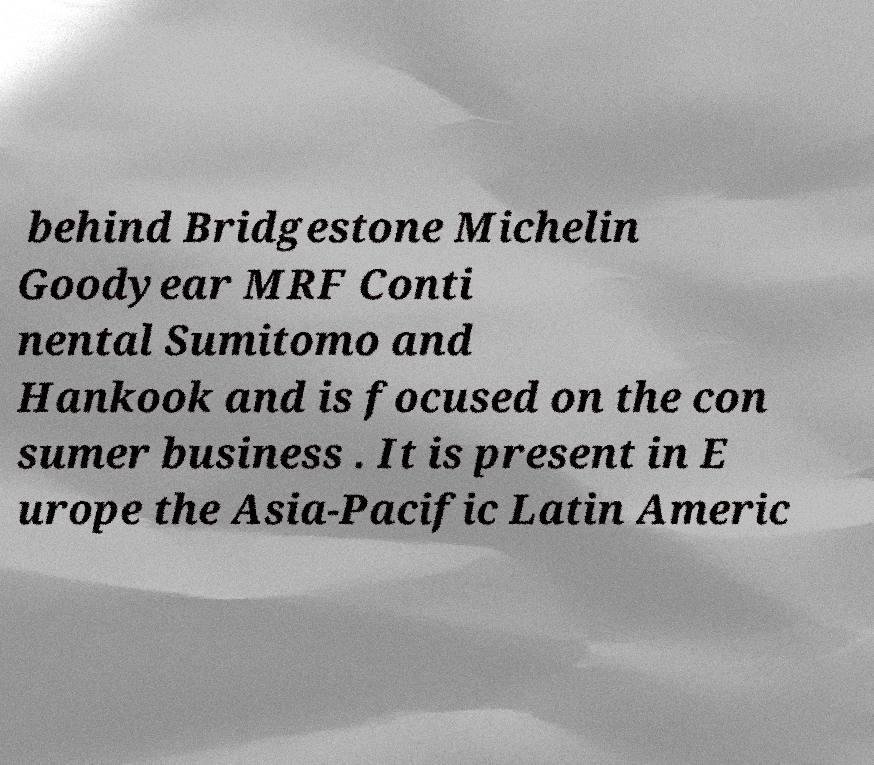Could you assist in decoding the text presented in this image and type it out clearly? behind Bridgestone Michelin Goodyear MRF Conti nental Sumitomo and Hankook and is focused on the con sumer business . It is present in E urope the Asia-Pacific Latin Americ 